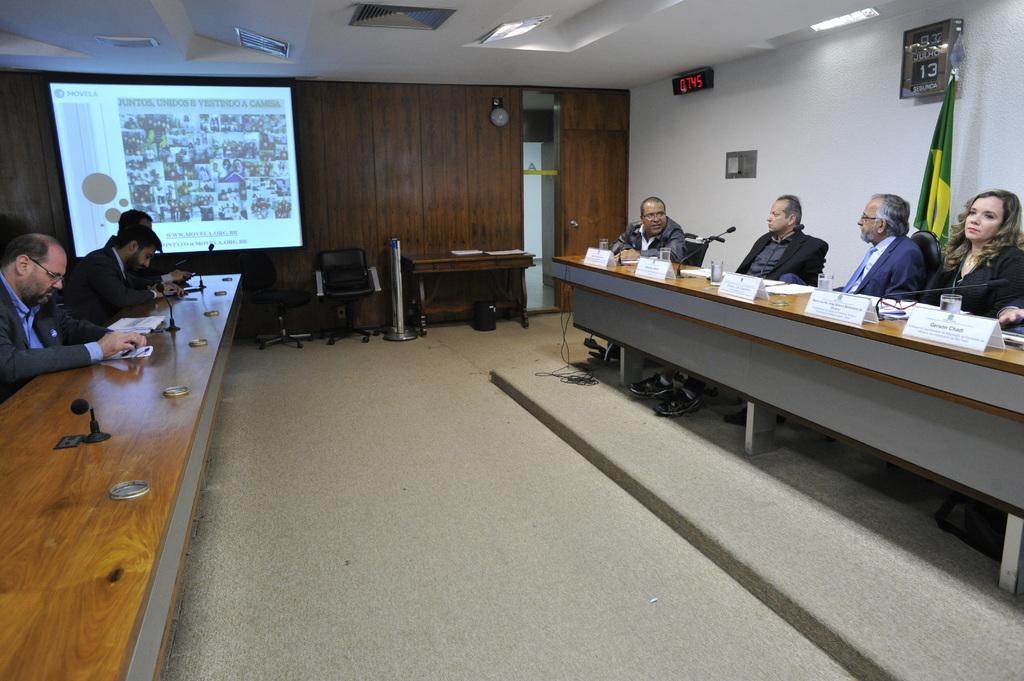How would you summarize this image in a sentence or two? This is a conference room where we have two desk each side and people sitting behind them and on the desk we have some miles and notes and glasses and to the other wall we have a screen and a desk on which some papers are placed and a chair. 